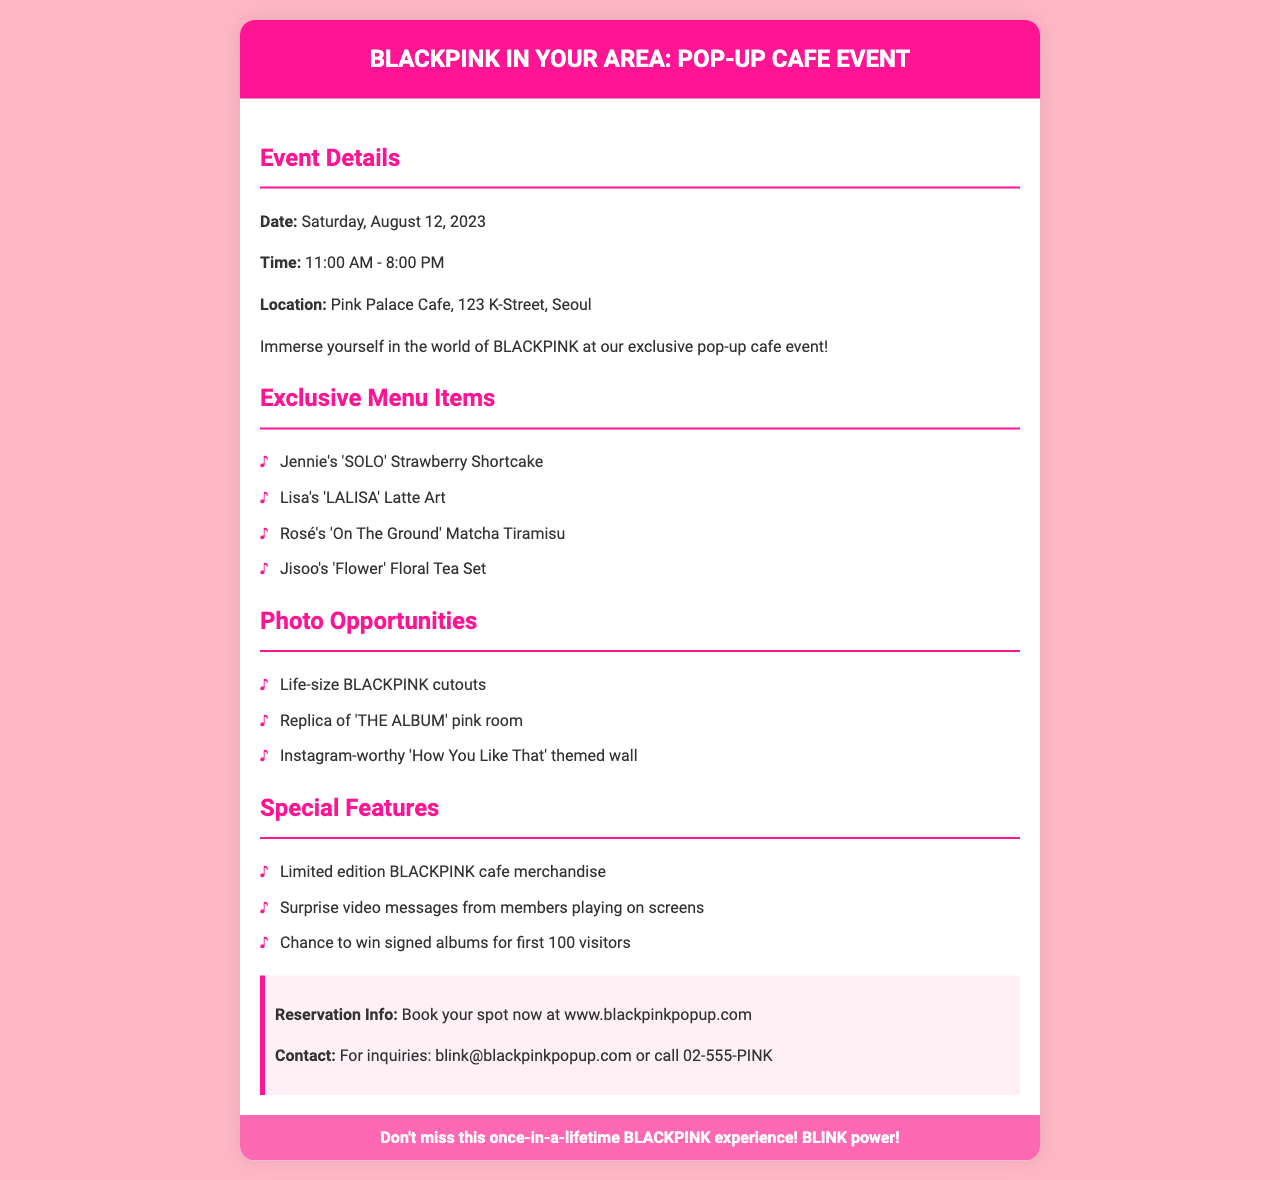What is the date of the event? The date of the event is directly mentioned in the document under "Event Details."
Answer: Saturday, August 12, 2023 What time does the pop-up cafe open? The opening time is listed in the "Event Details" section of the document.
Answer: 11:00 AM Where is the pop-up cafe located? The location is provided in the "Event Details" section of the document.
Answer: Pink Palace Cafe, 123 K-Street, Seoul What menu item is named after Lisa? The exclusive menu items include names inspired by the members, specifically listed under "Exclusive Menu Items."
Answer: Lisa's 'LALISA' Latte Art How many photo opportunities are listed? The number of photo opportunities can be counted from the "Photo Opportunities" section.
Answer: Three What is a special feature available at the event? The special features are listed under "Special Features," which highlights unique aspects of the event.
Answer: Limited edition BLACKPINK cafe merchandise What should attendees do to reserve a spot? Reservation instructions are found in the "Reservation Info" section of the document.
Answer: Book your spot now at www.blackpinkpopup.com What is the contact email for inquiries? The contact information is included in the "Reservation Info" section.
Answer: blink@blackpinkpopup.com 